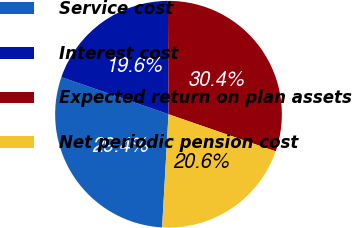Convert chart to OTSL. <chart><loc_0><loc_0><loc_500><loc_500><pie_chart><fcel>Service cost<fcel>Interest cost<fcel>Expected return on plan assets<fcel>Net periodic pension cost<nl><fcel>29.41%<fcel>19.61%<fcel>30.39%<fcel>20.59%<nl></chart> 